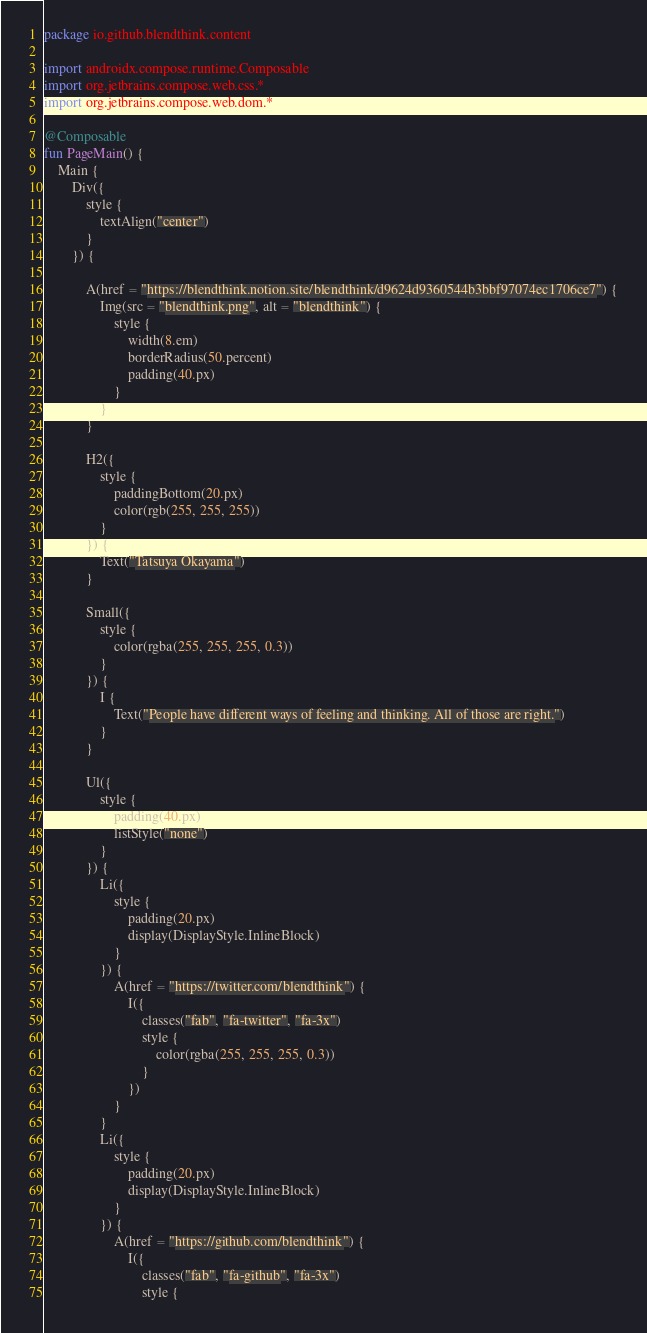Convert code to text. <code><loc_0><loc_0><loc_500><loc_500><_Kotlin_>package io.github.blendthink.content

import androidx.compose.runtime.Composable
import org.jetbrains.compose.web.css.*
import org.jetbrains.compose.web.dom.*

@Composable
fun PageMain() {
    Main {
        Div({
            style {
                textAlign("center")
            }
        }) {

            A(href = "https://blendthink.notion.site/blendthink/d9624d9360544b3bbf97074ec1706ce7") {
                Img(src = "blendthink.png", alt = "blendthink") {
                    style {
                        width(8.em)
                        borderRadius(50.percent)
                        padding(40.px)
                    }
                }
            }

            H2({
                style {
                    paddingBottom(20.px)
                    color(rgb(255, 255, 255))
                }
            }) {
                Text("Tatsuya Okayama")
            }

            Small({
                style {
                    color(rgba(255, 255, 255, 0.3))
                }
            }) {
                I {
                    Text("People have different ways of feeling and thinking. All of those are right.")
                }
            }

            Ul({
                style {
                    padding(40.px)
                    listStyle("none")
                }
            }) {
                Li({
                    style {
                        padding(20.px)
                        display(DisplayStyle.InlineBlock)
                    }
                }) {
                    A(href = "https://twitter.com/blendthink") {
                        I({
                            classes("fab", "fa-twitter", "fa-3x")
                            style {
                                color(rgba(255, 255, 255, 0.3))
                            }
                        })
                    }
                }
                Li({
                    style {
                        padding(20.px)
                        display(DisplayStyle.InlineBlock)
                    }
                }) {
                    A(href = "https://github.com/blendthink") {
                        I({
                            classes("fab", "fa-github", "fa-3x")
                            style {</code> 